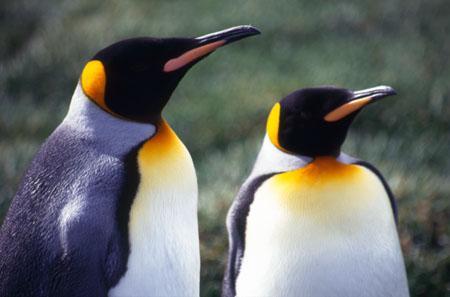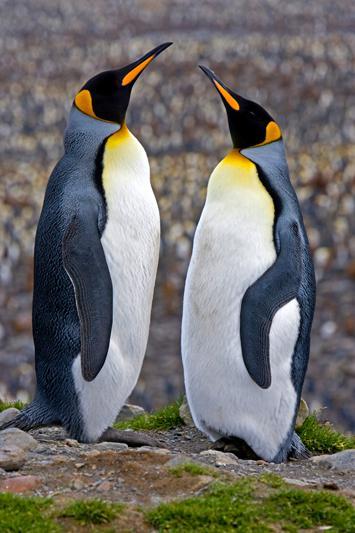The first image is the image on the left, the second image is the image on the right. Examine the images to the left and right. Is the description "There are four penguins" accurate? Answer yes or no. Yes. 